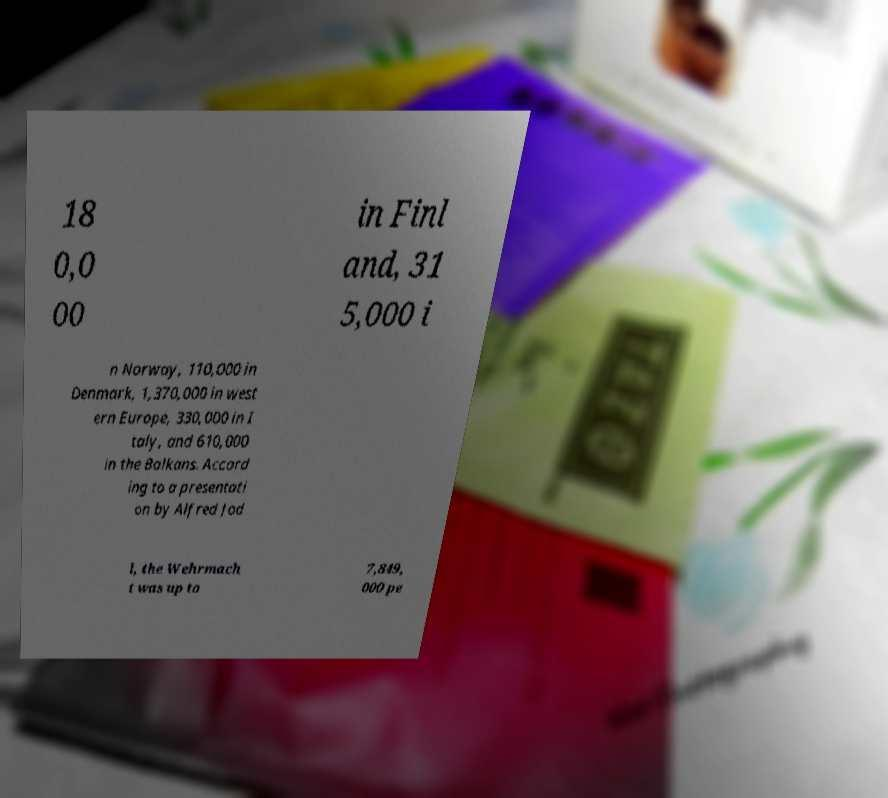For documentation purposes, I need the text within this image transcribed. Could you provide that? 18 0,0 00 in Finl and, 31 5,000 i n Norway, 110,000 in Denmark, 1,370,000 in west ern Europe, 330,000 in I taly, and 610,000 in the Balkans. Accord ing to a presentati on by Alfred Jod l, the Wehrmach t was up to 7,849, 000 pe 